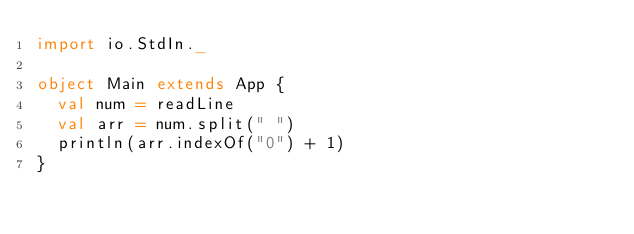<code> <loc_0><loc_0><loc_500><loc_500><_Scala_>import io.StdIn._
 
object Main extends App {
  val num = readLine
  val arr = num.split(" ")
  println(arr.indexOf("0") + 1)
}</code> 